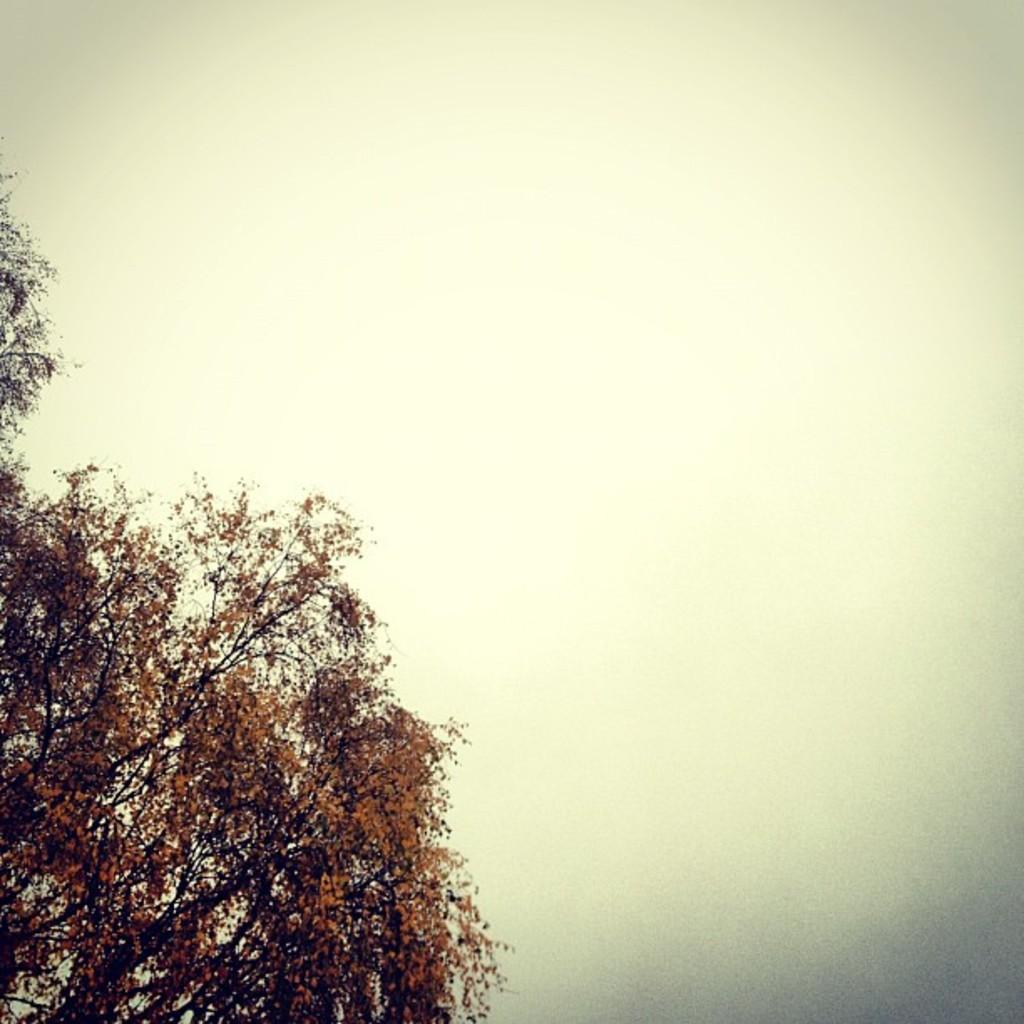What type of vegetation can be seen in the image? There are a few trees in the image. What part of the natural environment is visible in the image? The sky is visible in the image. What type of juice is being served on the bed in the image? There is no bed or juice present in the image; it only features trees and the sky. 